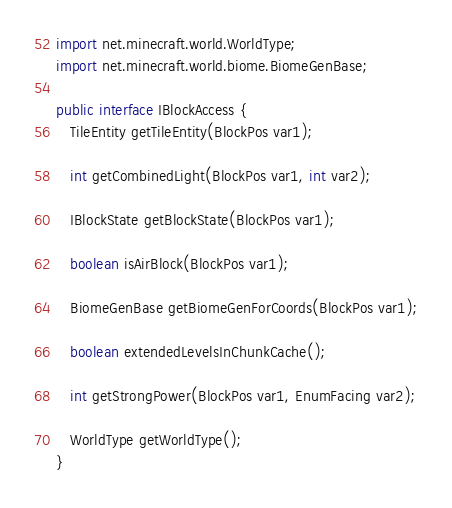Convert code to text. <code><loc_0><loc_0><loc_500><loc_500><_Java_>import net.minecraft.world.WorldType;
import net.minecraft.world.biome.BiomeGenBase;

public interface IBlockAccess {
   TileEntity getTileEntity(BlockPos var1);

   int getCombinedLight(BlockPos var1, int var2);

   IBlockState getBlockState(BlockPos var1);

   boolean isAirBlock(BlockPos var1);

   BiomeGenBase getBiomeGenForCoords(BlockPos var1);

   boolean extendedLevelsInChunkCache();

   int getStrongPower(BlockPos var1, EnumFacing var2);

   WorldType getWorldType();
}
</code> 